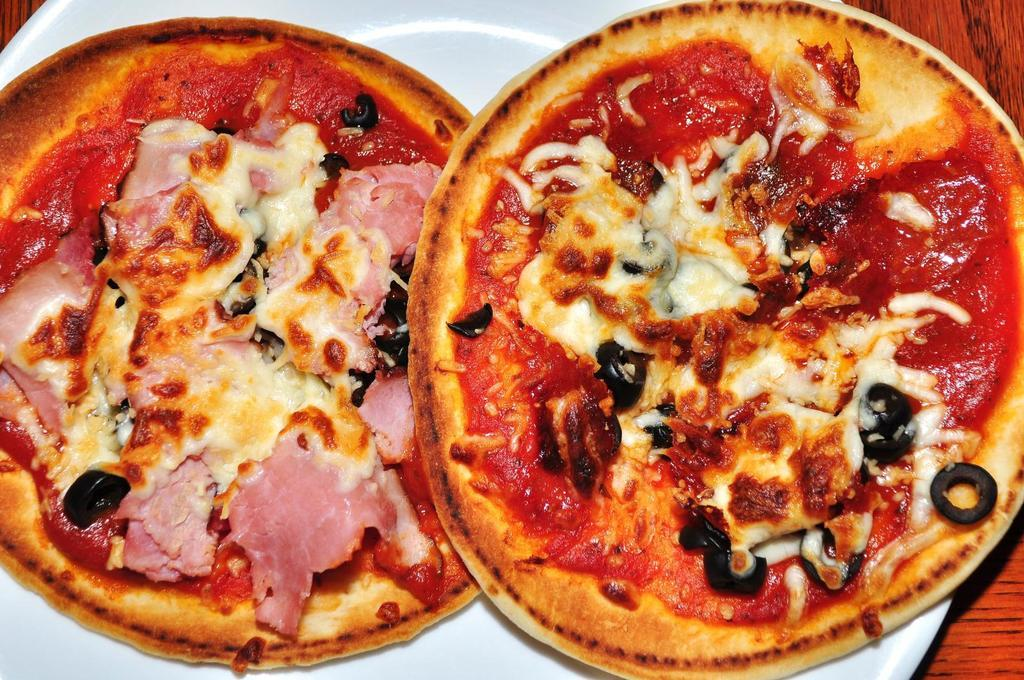What color is the plate in the image? The plate in the image is white colored. What is the plate placed on in the image? The plate is on a brown colored table. What can be found on the plate? There are food items in the plate. Are there any tanks visible in the image? No, there are no tanks present in the image. Can you see any cobwebs on the plate or table in the image? No, there are no cobwebs visible in the image. 